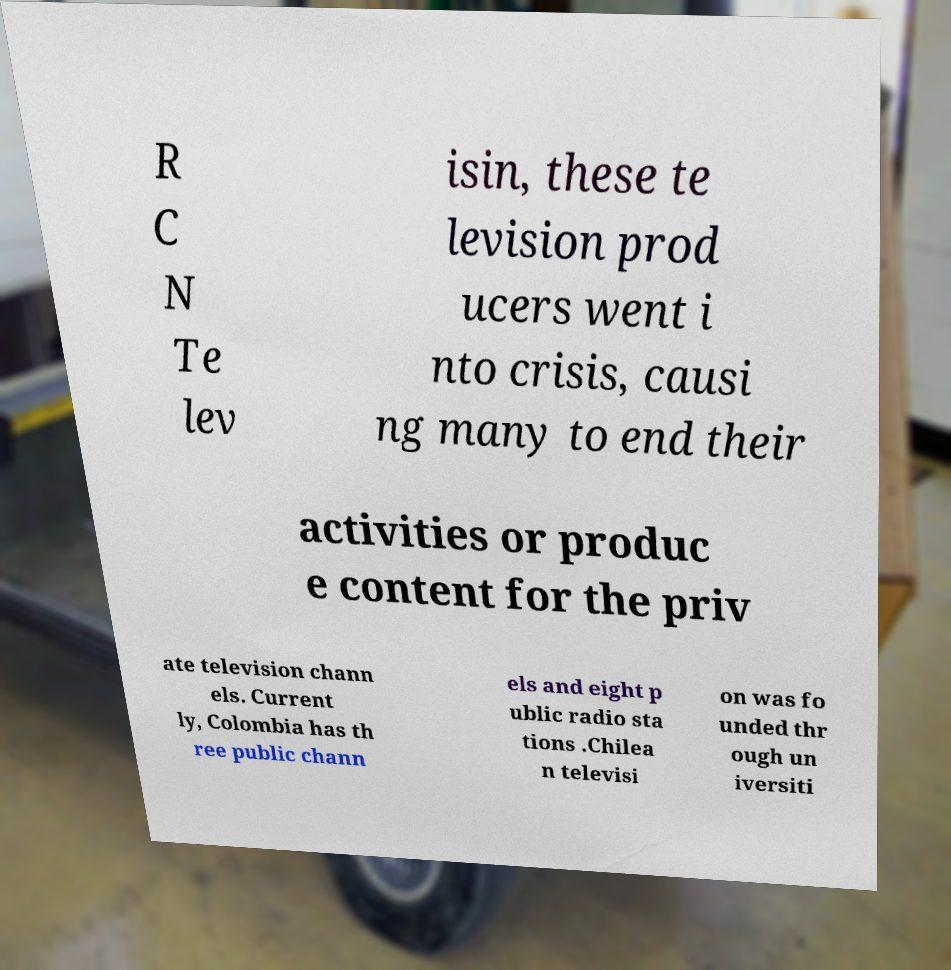Please identify and transcribe the text found in this image. R C N Te lev isin, these te levision prod ucers went i nto crisis, causi ng many to end their activities or produc e content for the priv ate television chann els. Current ly, Colombia has th ree public chann els and eight p ublic radio sta tions .Chilea n televisi on was fo unded thr ough un iversiti 